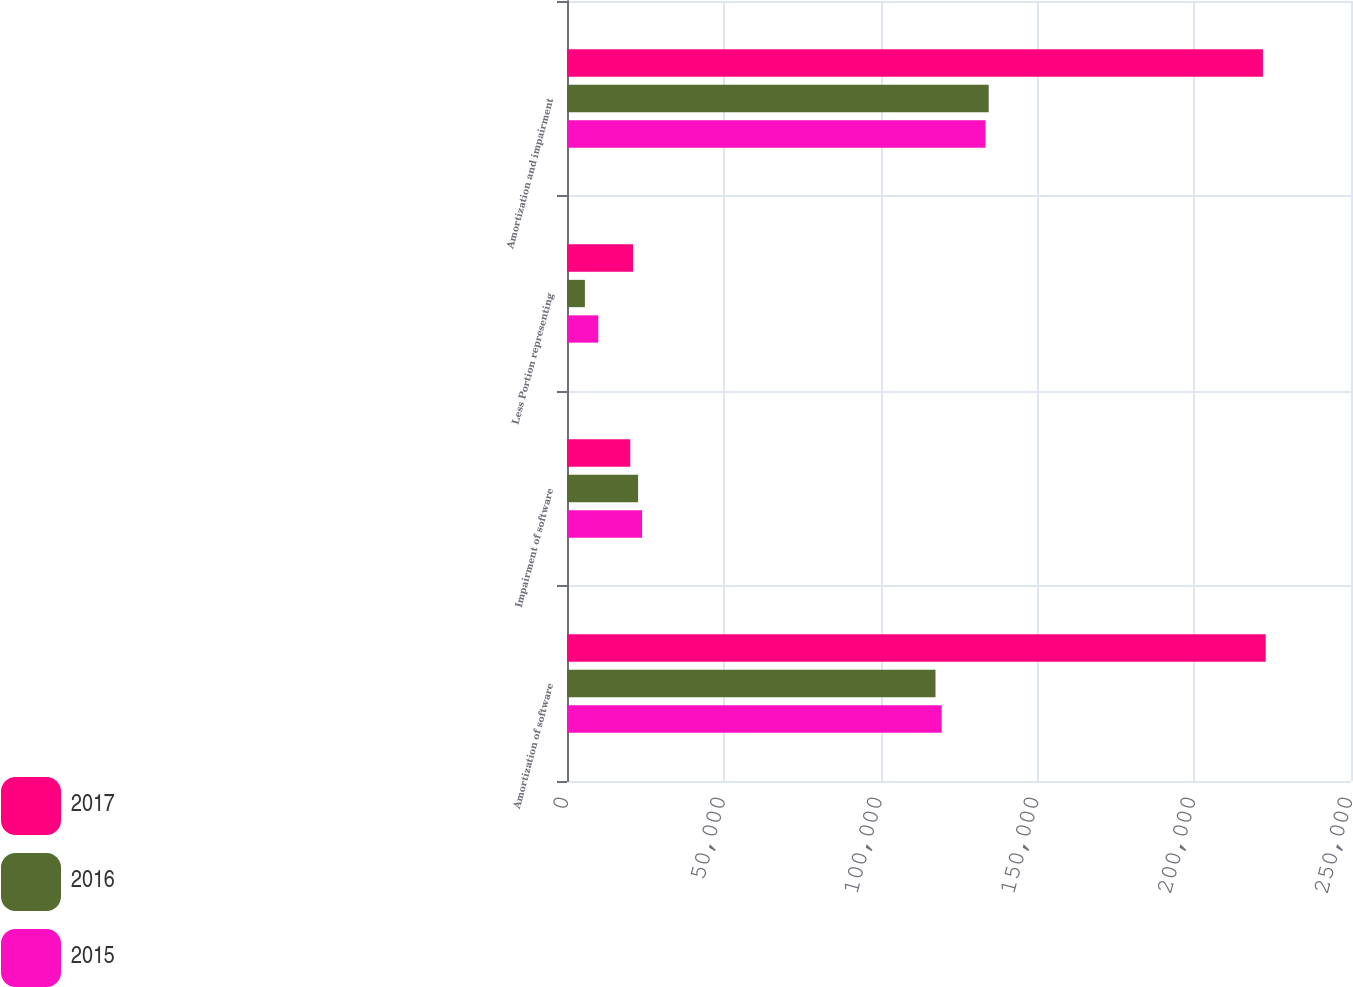Convert chart to OTSL. <chart><loc_0><loc_0><loc_500><loc_500><stacked_bar_chart><ecel><fcel>Amortization of software<fcel>Impairment of software<fcel>Less Portion representing<fcel>Amortization and impairment<nl><fcel>2017<fcel>222801<fcel>20166<fcel>21056<fcel>221911<nl><fcel>2016<fcel>117506<fcel>22671<fcel>5705<fcel>134472<nl><fcel>2015<fcel>119488<fcel>23947<fcel>9982<fcel>133453<nl></chart> 